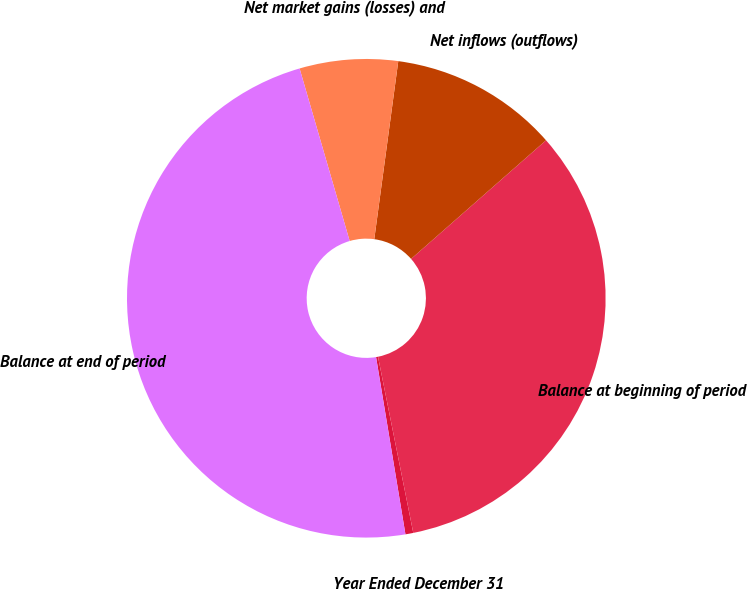Convert chart to OTSL. <chart><loc_0><loc_0><loc_500><loc_500><pie_chart><fcel>Year Ended December 31<fcel>Balance at beginning of period<fcel>Net inflows (outflows)<fcel>Net market gains (losses) and<fcel>Balance at end of period<nl><fcel>0.53%<fcel>33.33%<fcel>11.39%<fcel>6.63%<fcel>48.12%<nl></chart> 